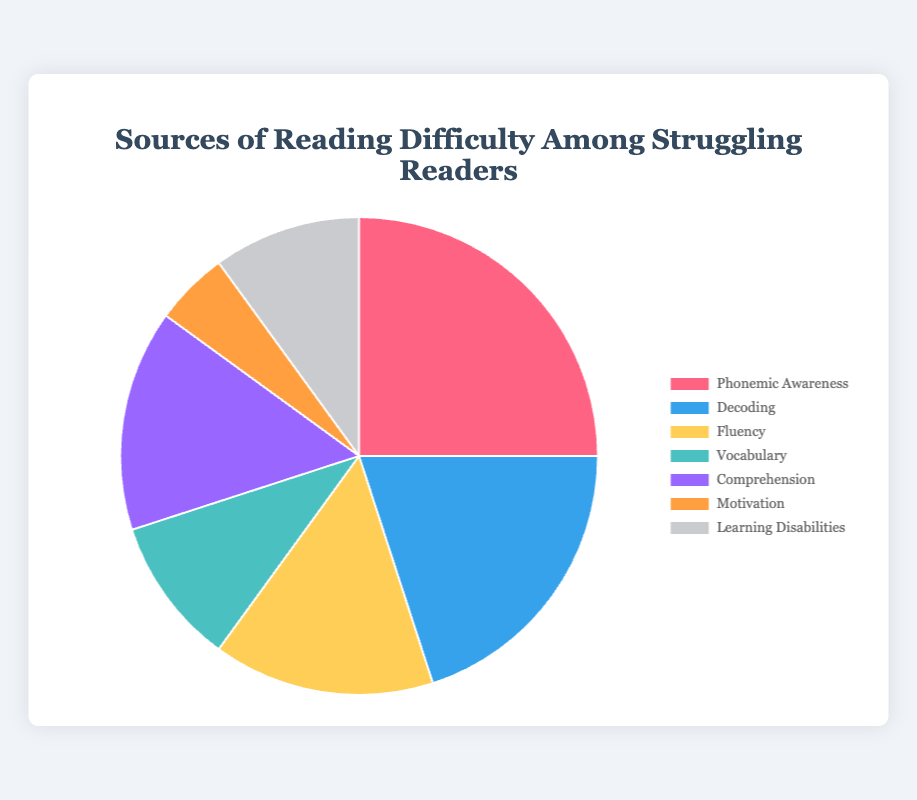What is the category with the highest percentage of reading difficulties? The category with the highest percentage of reading difficulties can be identified directly from the pie chart by examining the segment representing the largest portion. In this case, "Phonemic Awareness" represents 25%.
Answer: Phonemic Awareness Which two categories have the same percentage of reading difficulties? By looking at the segments of the pie chart, we can see that "Fluency" and "Comprehension" each represent 15%.
Answer: Fluency and Comprehension What is the total percentage of reading difficulties attributed to "Decoding," "Vocabulary," and "Learning Disabilities"? To find the total percentage for these three categories, we sum their individual percentages: "Decoding" (20%), "Vocabulary" (10%), and "Learning Disabilities" (10%). The total is 20% + 10% + 10% = 40%.
Answer: 40% Which category contributes the least to reading difficulties? By examining the pie chart, the smallest segment represents "Motivation," which is 5%.
Answer: Motivation How much greater is the percentage of difficulties in "Phonemic Awareness" compared to "Fluency"? The percentage for "Phonemic Awareness" is 25%, and for "Fluency" it is 15%. The difference is 25% - 15% = 10%.
Answer: 10% What is the combined percentage of reading difficulties related to "Phonemic Awareness" and "Decoding"? We sum the percentages for "Phonemic Awareness" (25%) and "Decoding" (20%). The combined total is 25% + 20% = 45%.
Answer: 45% Which category is represented by the blue color in the pie chart? In the pie chart, the blue color corresponds to the "Decoding" category.
Answer: Decoding How much less is the percentage of reading difficulties in "Motivation" compared to the total percentage of "Vocabulary" and "Learning Disabilities"? First, find the total percentage for "Vocabulary" and "Learning Disabilities" by adding them: 10% + 10% = 20%. Then, subtract the percentage of "Motivation" (5%) from this total: 20% - 5% = 15%.
Answer: 15% What is the difference in percentage between the highest and lowest categories of reading difficulties? The highest percentage is for "Phonemic Awareness" (25%) and the lowest is for "Motivation" (5%). The difference is 25% - 5% = 20%.
Answer: 20% What percentage of reading difficulties is attributed to comprehension? The segment for "Comprehension" in the pie chart represents 15%.
Answer: 15% 